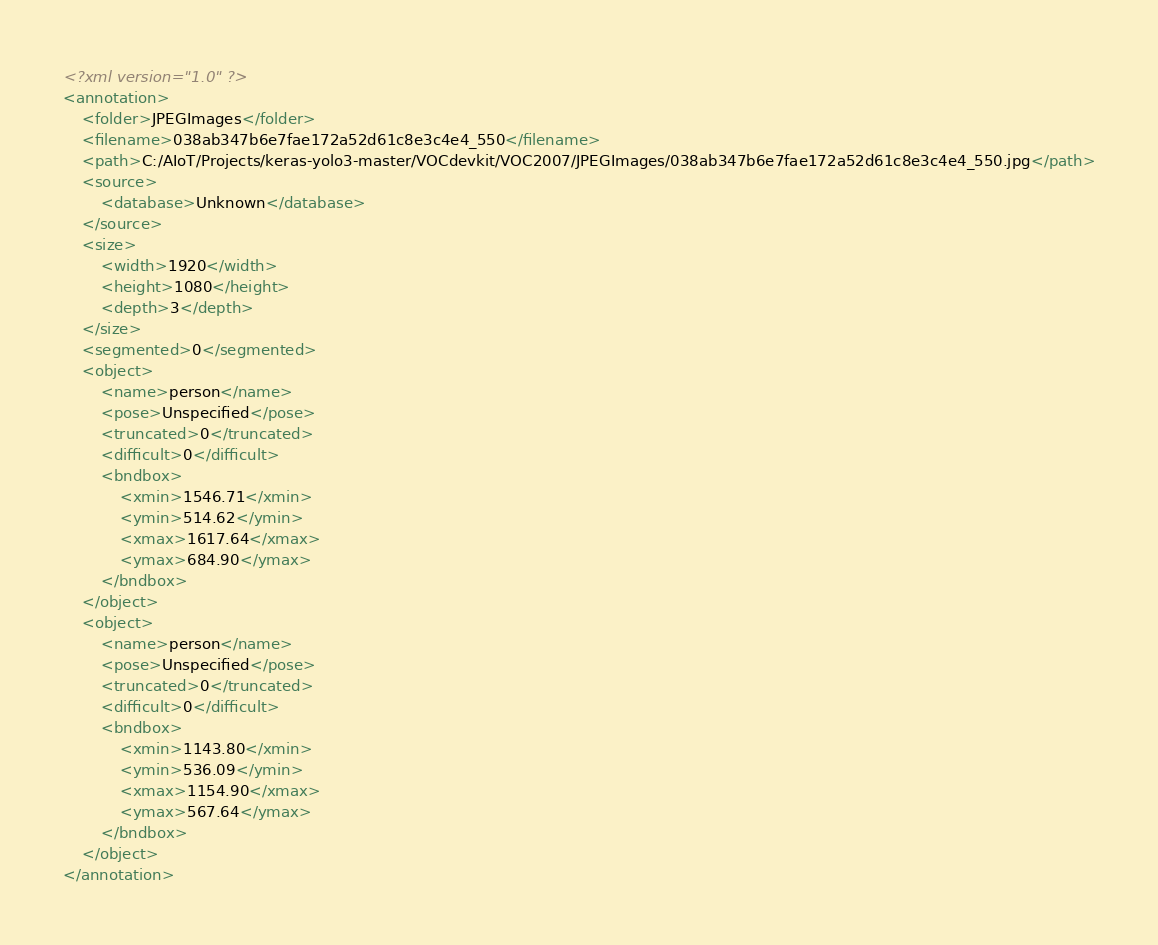<code> <loc_0><loc_0><loc_500><loc_500><_XML_><?xml version="1.0" ?>
<annotation>
	<folder>JPEGImages</folder>
	<filename>038ab347b6e7fae172a52d61c8e3c4e4_550</filename>
	<path>C:/AIoT/Projects/keras-yolo3-master/VOCdevkit/VOC2007/JPEGImages/038ab347b6e7fae172a52d61c8e3c4e4_550.jpg</path>
	<source>
		<database>Unknown</database>
	</source>
	<size>
		<width>1920</width>
		<height>1080</height>
		<depth>3</depth>
	</size>
	<segmented>0</segmented>
	<object>
		<name>person</name>
		<pose>Unspecified</pose>
		<truncated>0</truncated>
		<difficult>0</difficult>
		<bndbox>
			<xmin>1546.71</xmin>
			<ymin>514.62</ymin>
			<xmax>1617.64</xmax>
			<ymax>684.90</ymax>
		</bndbox>
	</object>
	<object>
		<name>person</name>
		<pose>Unspecified</pose>
		<truncated>0</truncated>
		<difficult>0</difficult>
		<bndbox>
			<xmin>1143.80</xmin>
			<ymin>536.09</ymin>
			<xmax>1154.90</xmax>
			<ymax>567.64</ymax>
		</bndbox>
	</object>
</annotation>
</code> 